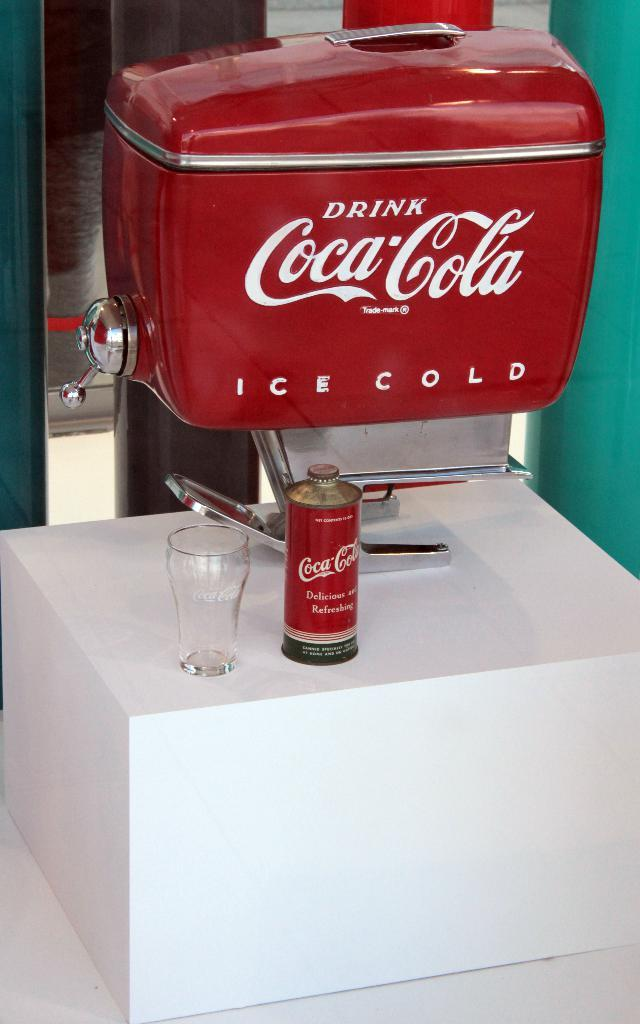What type of vending machine is in the image? There is a red color coke vending machine in the image. Where is the coke vending machine placed? The coke vending machine is placed on a white desk. What else can be seen on the desk? There is a glass on the desk. What does the queen use the coke vending machine for in the image? There is no queen present in the image, and therefore no such interaction can be observed. 